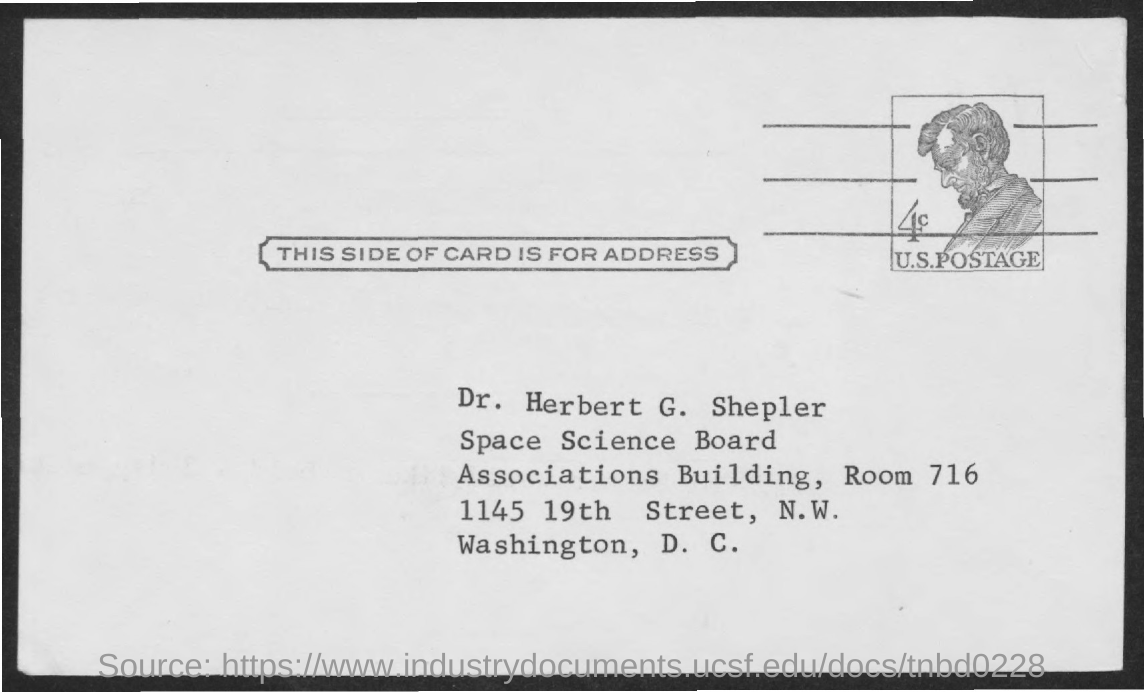Identify some key points in this picture. I, [Your Name], declare that the document's title is [Title of Document], and this side of the card is intended for address information. The text written below the image is, "U.S. Postage. The room number is 716. 